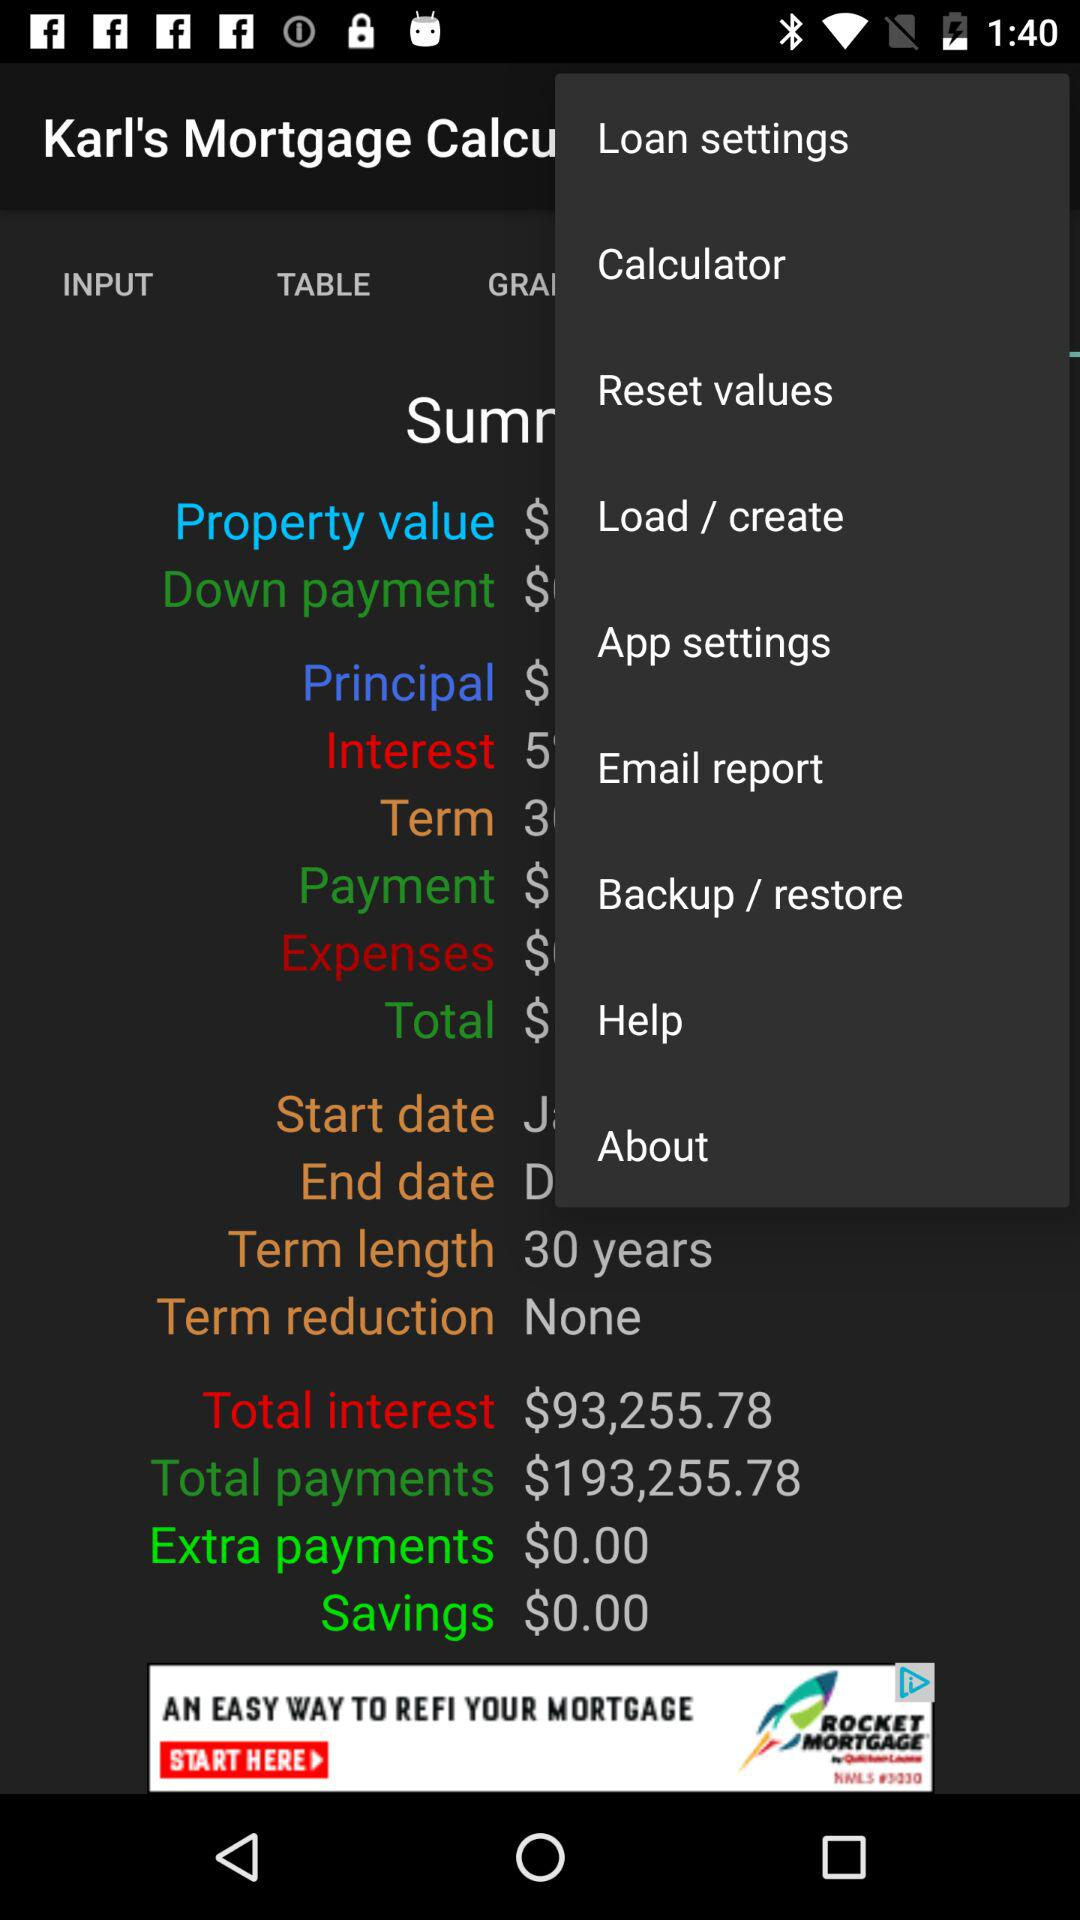How much is the total amount of savings over the life of the loan?
Answer the question using a single word or phrase. $0.00 